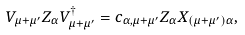<formula> <loc_0><loc_0><loc_500><loc_500>V _ { \mu + \mu ^ { \prime } } Z _ { \alpha } V _ { \mu + \mu ^ { \prime } } ^ { \dag } = c _ { \alpha , \mu + \mu ^ { \prime } } Z _ { \alpha } X _ { \left ( \mu + \mu ^ { \prime } \right ) \alpha } ,</formula> 